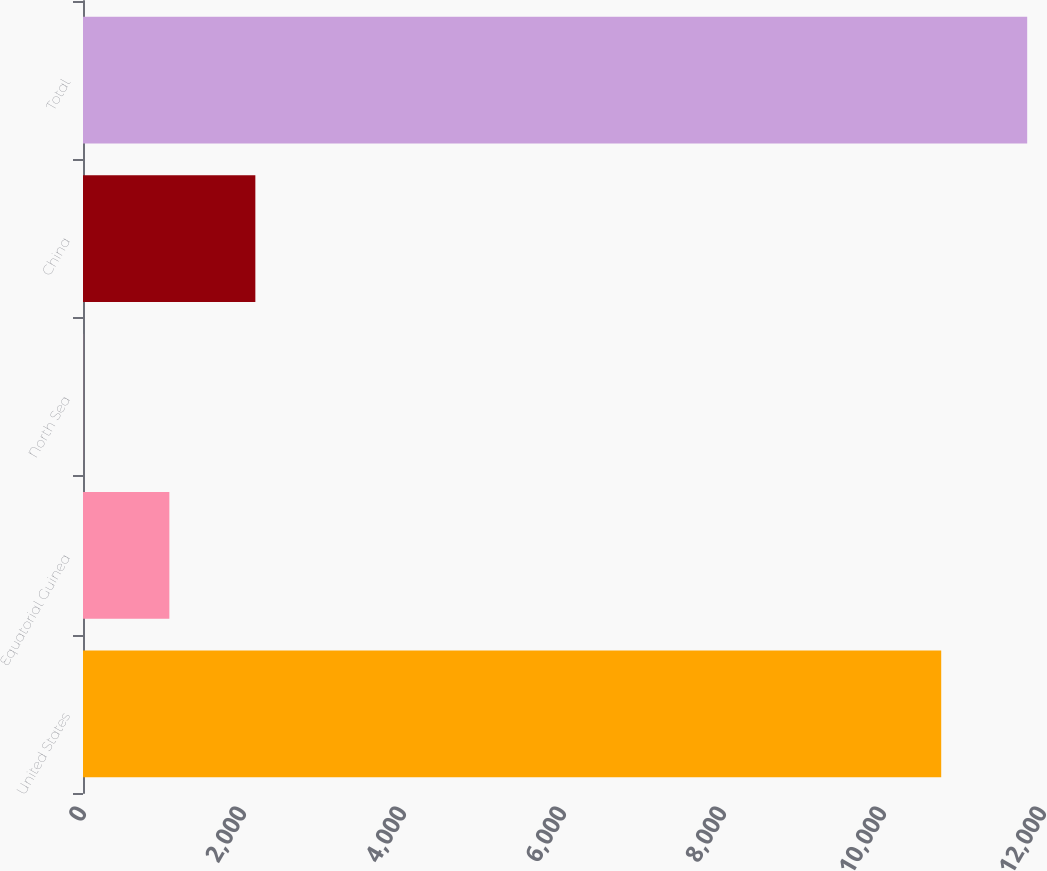Convert chart to OTSL. <chart><loc_0><loc_0><loc_500><loc_500><bar_chart><fcel>United States<fcel>Equatorial Guinea<fcel>North Sea<fcel>China<fcel>Total<nl><fcel>10727.6<fcel>1079.58<fcel>4.8<fcel>2154.36<fcel>11802.4<nl></chart> 